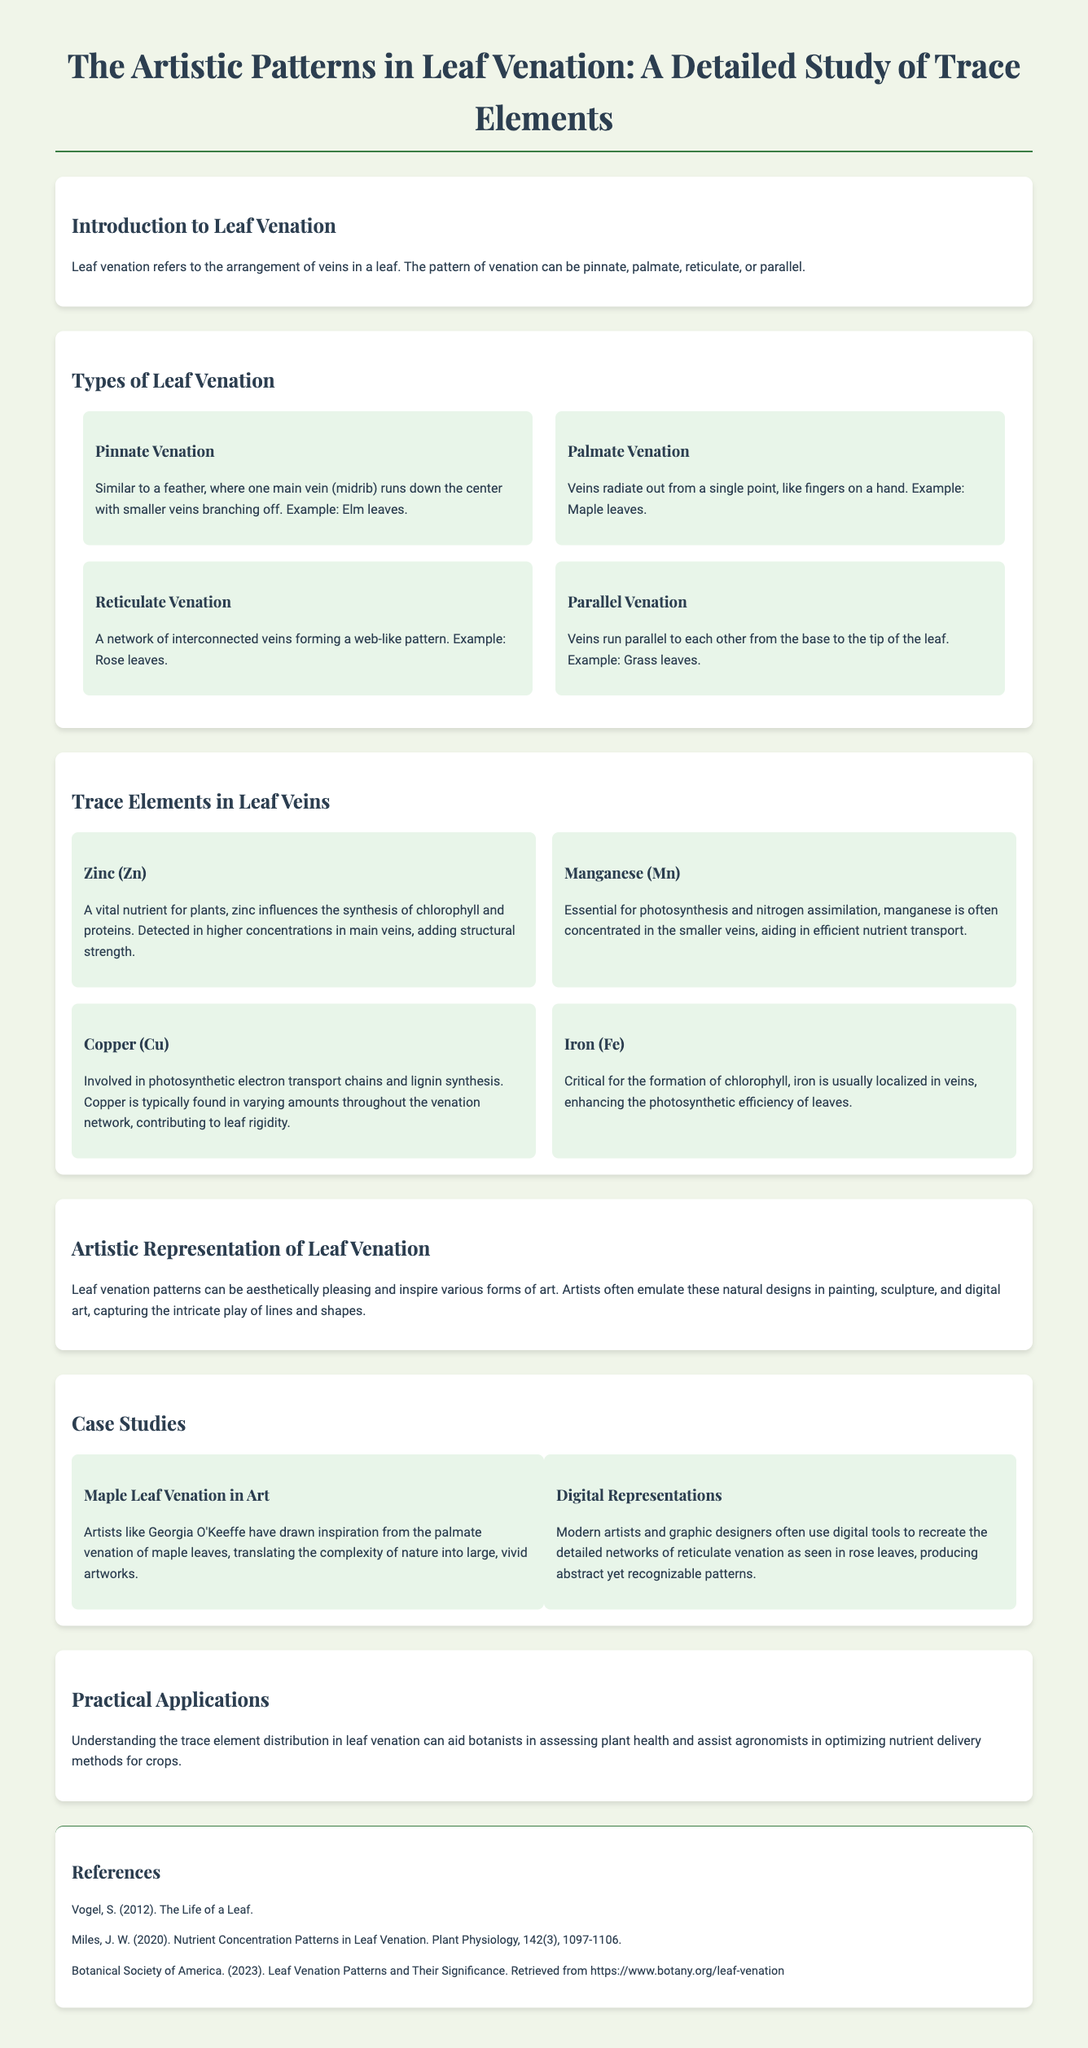What is leaf venation? Leaf venation refers to the arrangement of veins in a leaf.
Answer: Arrangement of veins What type of leaf venation resembles a feather? The document describes pinnate venation as similar to a feather.
Answer: Pinnate venation Which trace element is critical for the formation of chlorophyll? The document specifies iron as critical for chlorophyll formation.
Answer: Iron What artist drew inspiration from maple leaf venation? The document mentions Georgia O'Keeffe as an artist inspired by maple leaves.
Answer: Georgia O'Keeffe What is the practical application of understanding trace element distribution in leaf venation? Understanding trace element distribution aids botanists in assessing plant health.
Answer: Assessing plant health How many types of leaf venation are discussed in the document? The document lists four types of leaf venation: pinnate, palmate, reticulate, and parallel.
Answer: Four types What design pattern do digital artists recreate from leaf venation? The document states that digital artists recreate networks of reticulate venation.
Answer: Reticulate venation Which trace element is involved in photosynthetic electron transport chains? The document notes that copper is involved in photosynthetic electron transport chains.
Answer: Copper What type of document is this? The document is characterized as an infographic focusing on artistic patterns in leaf venation.
Answer: Infographic 